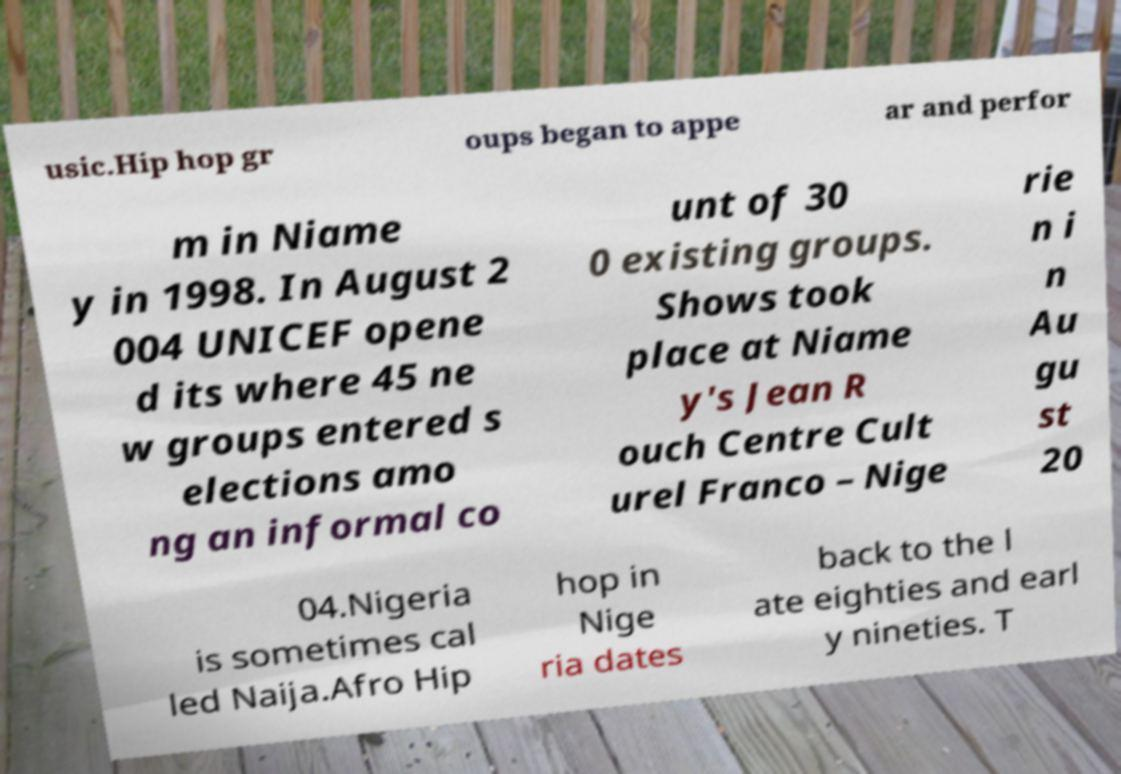For documentation purposes, I need the text within this image transcribed. Could you provide that? usic.Hip hop gr oups began to appe ar and perfor m in Niame y in 1998. In August 2 004 UNICEF opene d its where 45 ne w groups entered s elections amo ng an informal co unt of 30 0 existing groups. Shows took place at Niame y's Jean R ouch Centre Cult urel Franco – Nige rie n i n Au gu st 20 04.Nigeria is sometimes cal led Naija.Afro Hip hop in Nige ria dates back to the l ate eighties and earl y nineties. T 